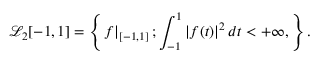Convert formula to latex. <formula><loc_0><loc_0><loc_500><loc_500>\mathcal { L } _ { 2 } [ - 1 , 1 ] = \left \{ f \right | _ { [ - 1 , 1 ] } ; \int _ { - 1 } ^ { 1 } \left | f ( t ) \right | ^ { 2 } d t < + \infty , \right \} .</formula> 